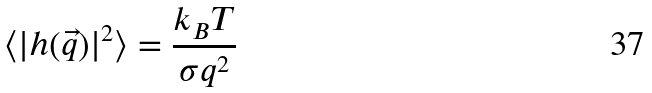<formula> <loc_0><loc_0><loc_500><loc_500>\langle | h ( \vec { q } ) | ^ { 2 } \rangle = \frac { k _ { B } T } { \sigma q ^ { 2 } }</formula> 